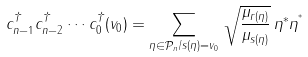Convert formula to latex. <formula><loc_0><loc_0><loc_500><loc_500>c _ { n - 1 } ^ { \dagger } c _ { n - 2 } ^ { \dagger } \cdots c _ { 0 } ^ { \dagger } ( v _ { 0 } ) = \sum _ { \eta \in \mathcal { P } _ { n } / s ( \eta ) = v _ { 0 } } \, \sqrt { \frac { \mu _ { r ( \eta ) } } { \mu _ { s ( \eta ) } } } \, \eta ^ { * } \eta ^ { ^ { * } }</formula> 